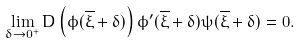Convert formula to latex. <formula><loc_0><loc_0><loc_500><loc_500>\lim _ { \delta \to 0 ^ { + } } D \left ( \phi ( \overline { \xi } + \delta ) \right ) \phi ^ { \prime } ( \overline { \xi } + \delta ) \psi ( \overline { \xi } + \delta ) = 0 .</formula> 